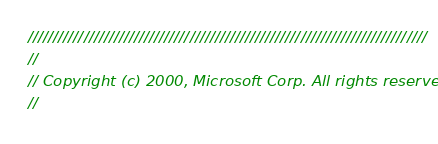Convert code to text. <code><loc_0><loc_0><loc_500><loc_500><_C++_>///////////////////////////////////////////////////////////////////////////////
//
// Copyright (c) 2000, Microsoft Corp. All rights reserved.
//</code> 